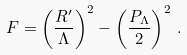Convert formula to latex. <formula><loc_0><loc_0><loc_500><loc_500>F = \left ( \frac { R ^ { \prime } } { \Lambda } \right ) ^ { 2 } - \left ( \frac { P _ { \Lambda } } { 2 } \right ) ^ { 2 } \, .</formula> 